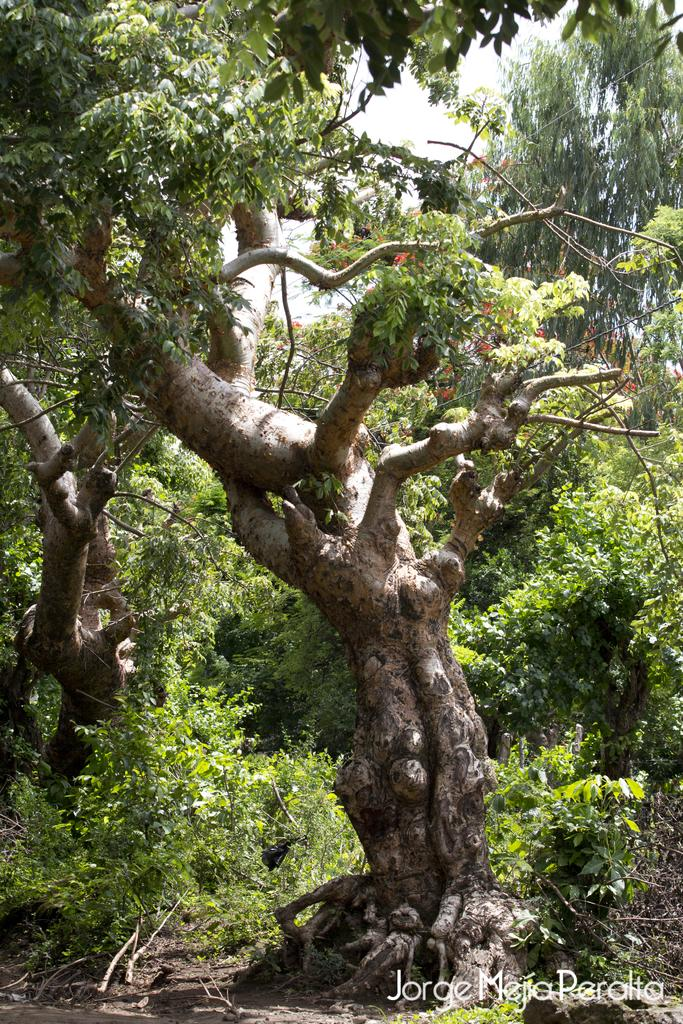What type of natural elements can be seen in the image? There are trees in the image. Is there any text or marking visible at the bottom of the image? Yes, there is a watermark at the bottom of the image. What flavor of ice cream is being served on the side of the trees? There is no ice cream or serving in the image; it only features trees and a watermark. 